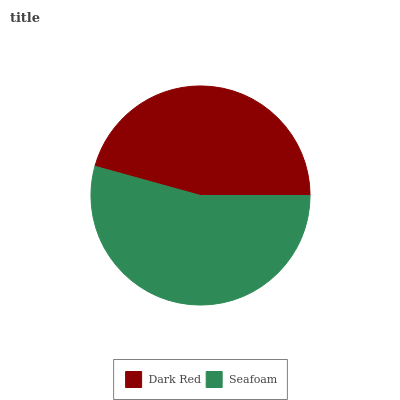Is Dark Red the minimum?
Answer yes or no. Yes. Is Seafoam the maximum?
Answer yes or no. Yes. Is Seafoam the minimum?
Answer yes or no. No. Is Seafoam greater than Dark Red?
Answer yes or no. Yes. Is Dark Red less than Seafoam?
Answer yes or no. Yes. Is Dark Red greater than Seafoam?
Answer yes or no. No. Is Seafoam less than Dark Red?
Answer yes or no. No. Is Seafoam the high median?
Answer yes or no. Yes. Is Dark Red the low median?
Answer yes or no. Yes. Is Dark Red the high median?
Answer yes or no. No. Is Seafoam the low median?
Answer yes or no. No. 